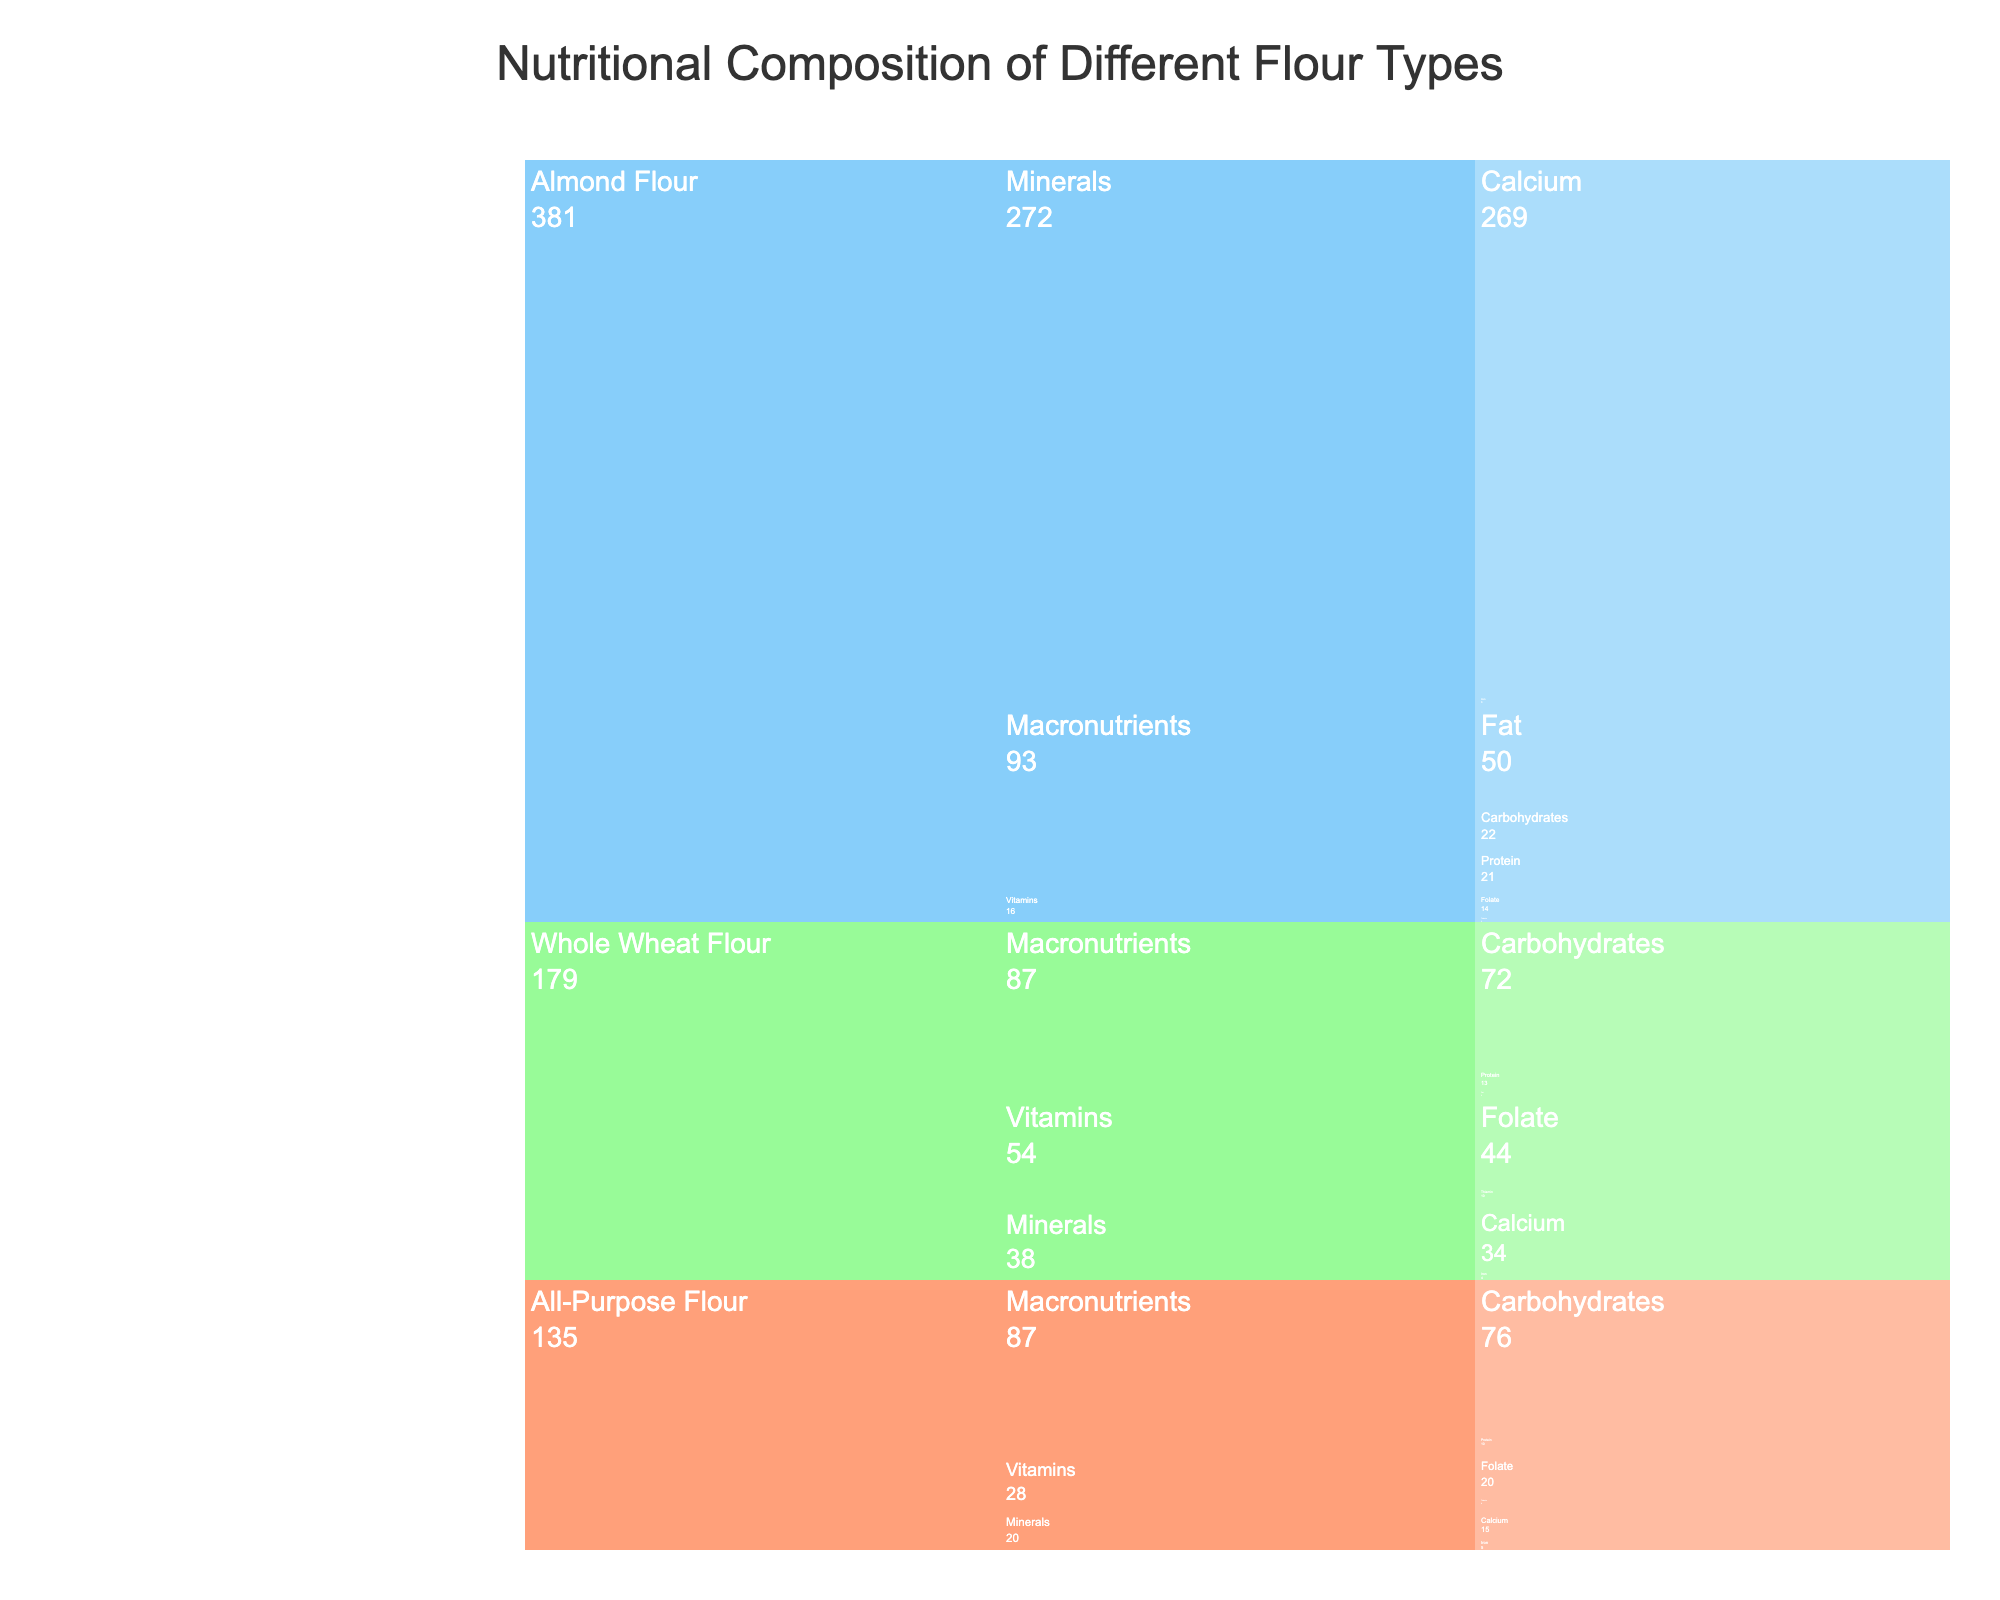**Basic Questions**
Q1: What is the title of the icicle chart? The title of the icicle chart is displayed at the top center of the figure. It reads "Nutritional Composition of Different Flour Types".
Answer: Nutritional Composition of Different Flour Types Q2: How many flour types are compared in the icicle chart? There are three flour types compared in the figure, each represented by a distinct color: All-Purpose Flour, Whole Wheat Flour, and Almond Flour.
Answer: Three **Compositional Questions**
Q3: What is the total carbohydrate content of All-Purpose Flour and Whole Wheat Flour combined? All-Purpose Flour has 76 grams of carbohydrates and Whole Wheat Flour has 72 grams. Adding these gives us 76 + 72 = 148 grams of carbohydrates.
Answer: 148 grams Q4: By how much does the protein content of Almond Flour exceed that of All-Purpose Flour? Almond Flour has 21 grams of protein, while All-Purpose Flour has 10 grams. The difference is 21 - 10 = 11 grams.
Answer: 11 grams **Comparison Questions**
Q5: Which flour has the highest calcium content? The calcium content can be found under the "Minerals" category for each flour. Almond Flour has the highest calcium content at 269 grams.
Answer: Almond Flour Q6: Which flour has the least amount of thiamin? Under the "Vitamins" category, Almond Flour has the least thiamin with a value of 2 grams.
Answer: Almond Flour **Chart-Type Specific Questions**
Q7: What is the color representation for Whole Wheat Flour in the icicle chart? The color of Whole Wheat Flour in the icicle chart is light green.
Answer: Light green Q8: How is the nutritional information structured in the icicle chart? The icicle chart groups the data in a hierarchical manner starting with Flour Type, followed by Category, and then Nutrient. Values are shown at the smallest level for the nutrients.
Answer: Hierarchically with Flour Type > Category > Nutrient **Intermediate**
Q9: What is the average fat content across all the flours? Add the fat content of all-purpose flour (1g), whole wheat flour (2g), and almond flour (50g). The total fat content is 1 + 2 + 50 = 53 grams. Since there are three samples, the average fat content is 53 / 3 ≈ 17.67 grams.
Answer: 17.67 grams 